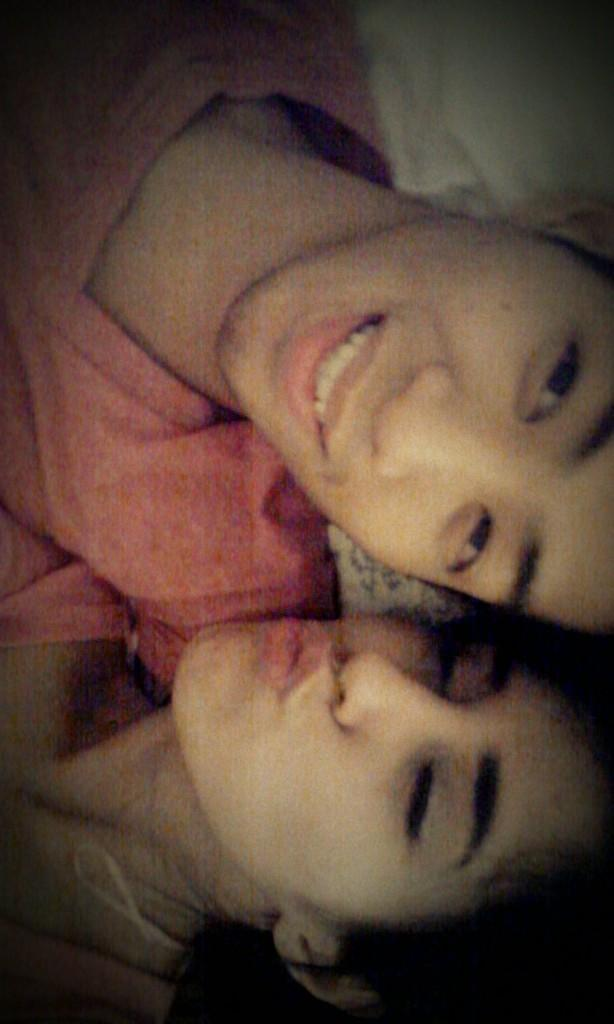What is the gender of the person in the image wearing a pink T-shirt? There are two people in the image wearing pink T-shirts, a man and a woman. What is the facial expression of the man in the image? The man in the image is smiling. What is the facial expression of the woman in the image? The woman in the image is also smiling. How many square cakes are on the table in the image? There is no table or cakes present in the image. What type of pigs can be seen in the image? There are no pigs present in the image. 